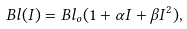Convert formula to latex. <formula><loc_0><loc_0><loc_500><loc_500>B l ( I ) = B l _ { o } ( 1 + \alpha I + \beta I ^ { 2 } ) ,</formula> 